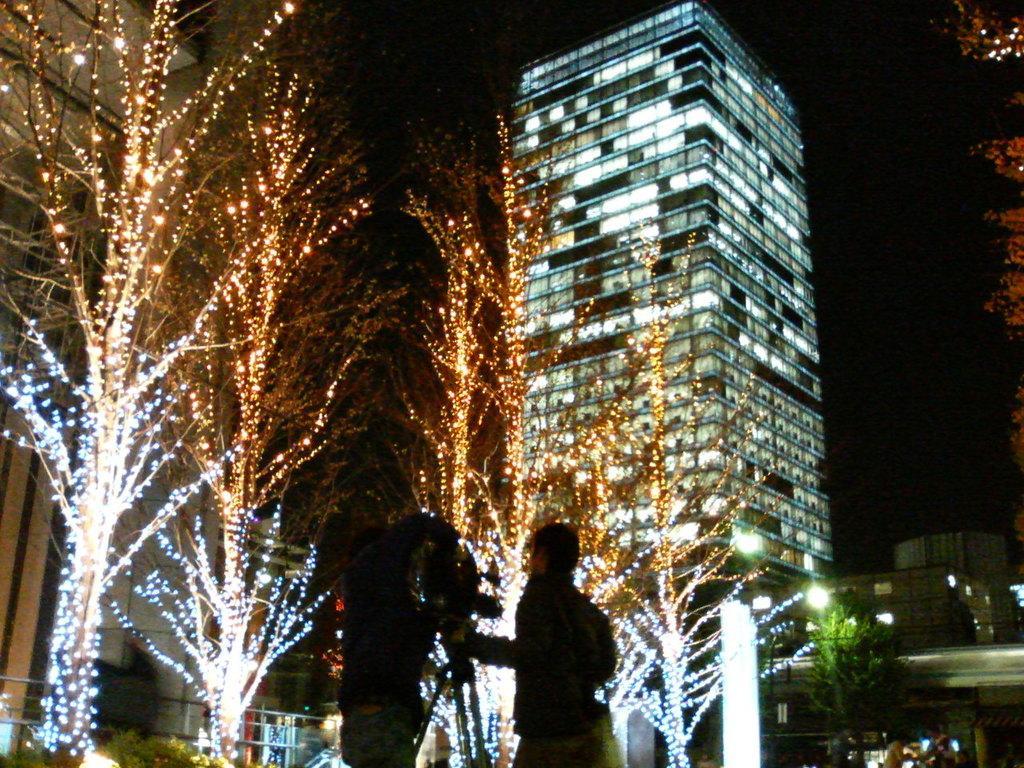Please provide a concise description of this image. In this image in front there are two people standing in front of the camera. In front of them there are trees, lights, buildings. In the background of the image there is sky. 